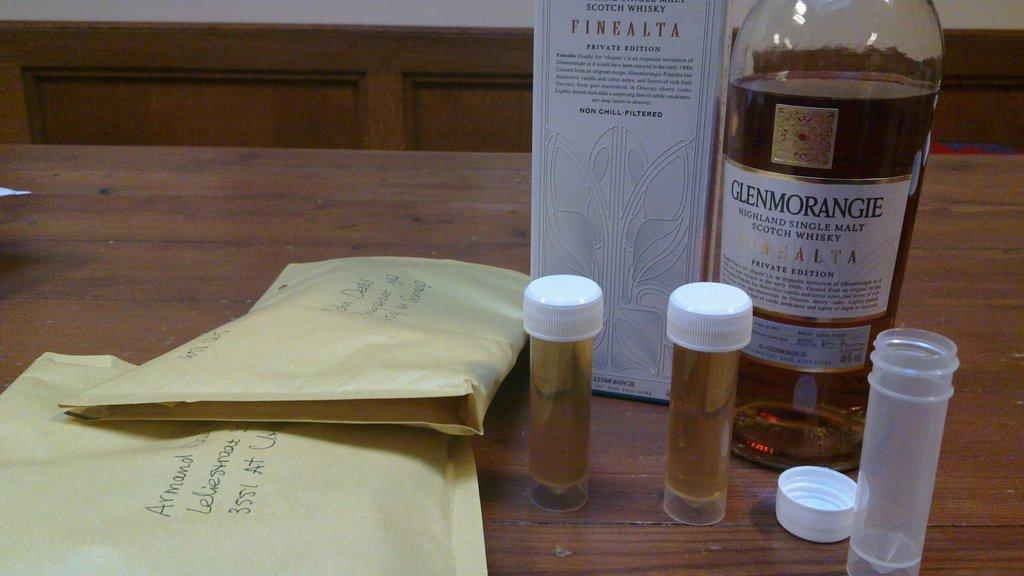<image>
Summarize the visual content of the image. A bottle and 2 samples of Glenmorangie single malt scotch whiskey 